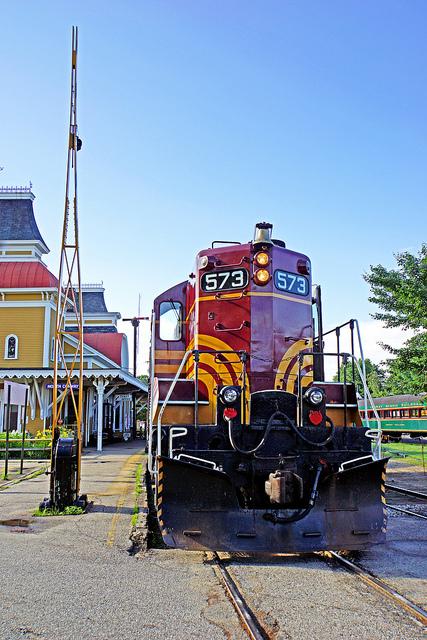Does the train have a track to run on?
Be succinct. Yes. What color is the train?
Keep it brief. Red. What color is the building to the left?
Keep it brief. Yellow, red and blue. Are there clouds on the sky?
Short answer required. No. How many people are headed towards the train?
Answer briefly. 0. Are there train tracks?
Be succinct. Yes. What is the color of the front of the train?
Short answer required. Red. Why is the road closed?
Write a very short answer. Train. What does the sign say?
Answer briefly. 573. What number is on the front of the train?
Concise answer only. 573. Is the train stopped?
Keep it brief. Yes. 